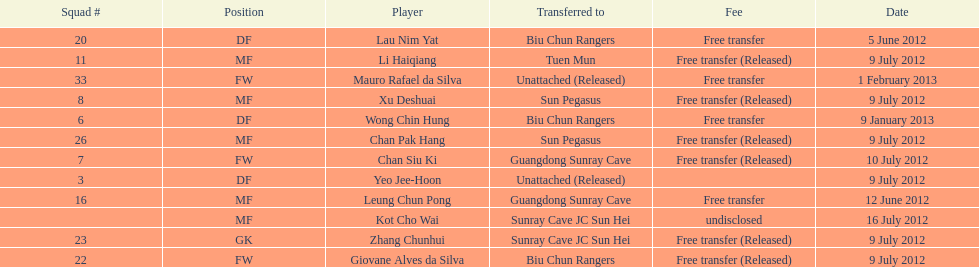Li haiqiang and xu deshuai both played which position? MF. 